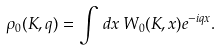<formula> <loc_0><loc_0><loc_500><loc_500>\rho _ { 0 } ( K , q ) = \int \, d x \, W _ { 0 } ( K , x ) e ^ { - i q x } .</formula> 